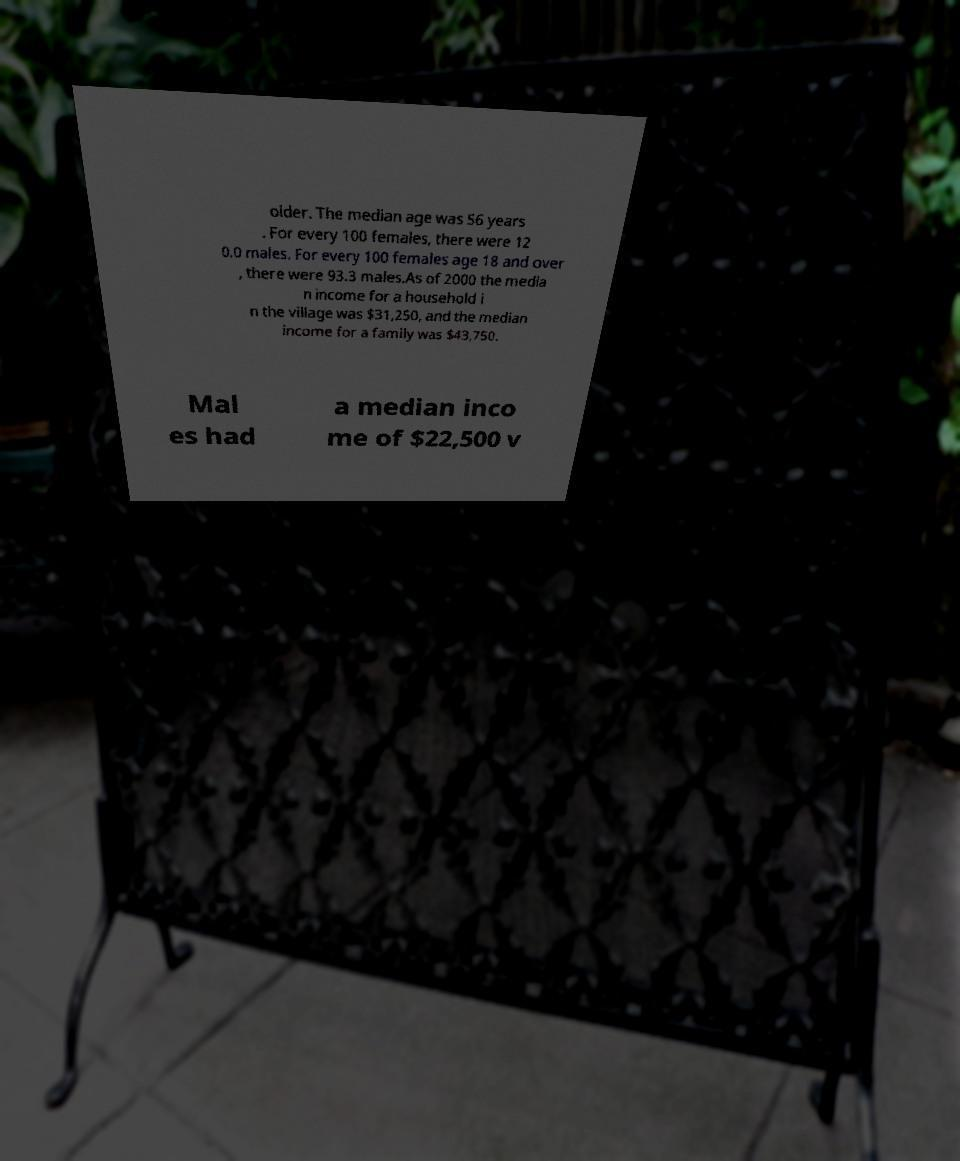What messages or text are displayed in this image? I need them in a readable, typed format. older. The median age was 56 years . For every 100 females, there were 12 0.0 males. For every 100 females age 18 and over , there were 93.3 males.As of 2000 the media n income for a household i n the village was $31,250, and the median income for a family was $43,750. Mal es had a median inco me of $22,500 v 